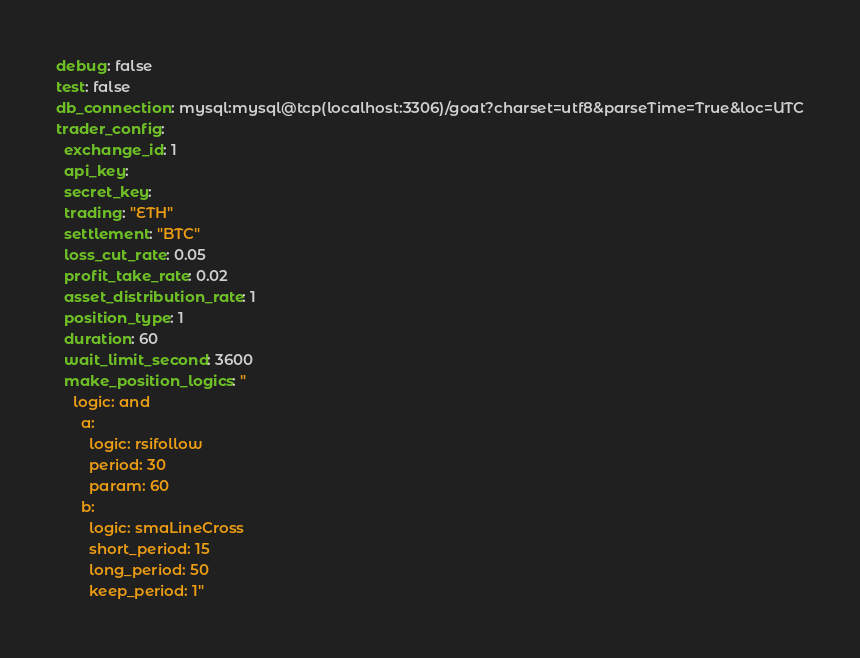<code> <loc_0><loc_0><loc_500><loc_500><_YAML_>debug: false
test: false
db_connection: mysql:mysql@tcp(localhost:3306)/goat?charset=utf8&parseTime=True&loc=UTC
trader_config:
  exchange_id: 1
  api_key:
  secret_key:
  trading: "ETH"
  settlement: "BTC"
  loss_cut_rate: 0.05
  profit_take_rate: 0.02
  asset_distribution_rate: 1
  position_type: 1
  duration: 60
  wait_limit_second: 3600
  make_position_logics: "
    logic: and
      a:
        logic: rsifollow
        period: 30
        param: 60
      b:
        logic: smaLineCross
        short_period: 15
        long_period: 50
        keep_period: 1"</code> 